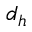<formula> <loc_0><loc_0><loc_500><loc_500>d _ { h }</formula> 